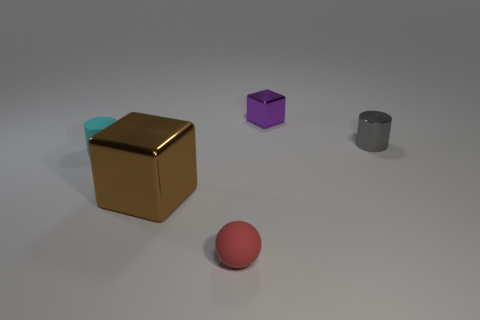The purple object that is the same size as the red sphere is what shape?
Make the answer very short. Cube. How many things are either metallic blocks that are behind the small cyan rubber thing or shiny cubes that are behind the gray object?
Provide a short and direct response. 1. What is the shape of the tiny cyan thing that is the same material as the red object?
Give a very brief answer. Cylinder. There is a small cyan object that is the same shape as the gray thing; what is it made of?
Offer a terse response. Rubber. How many other objects are there of the same size as the matte sphere?
Your answer should be compact. 3. What is the material of the gray thing?
Provide a succinct answer. Metal. Are there more small red rubber spheres in front of the small cyan matte cylinder than small green objects?
Your answer should be very brief. Yes. Is there a tiny blue shiny sphere?
Give a very brief answer. No. What number of other objects are there of the same shape as the brown metallic object?
Provide a short and direct response. 1. There is a cylinder that is left of the purple metallic block; is it the same color as the small cylinder on the right side of the tiny purple shiny thing?
Your answer should be very brief. No. 